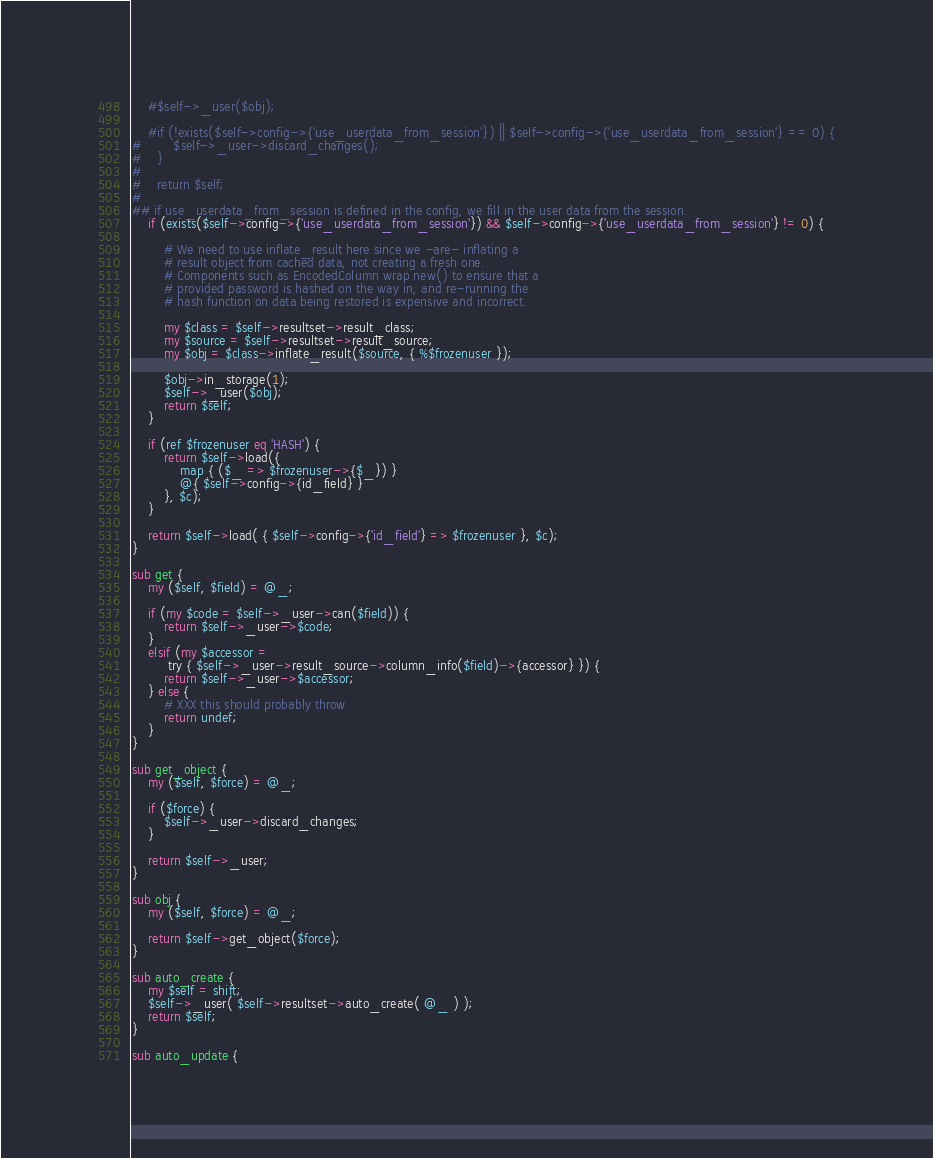Convert code to text. <code><loc_0><loc_0><loc_500><loc_500><_Perl_>    #$self->_user($obj);

    #if (!exists($self->config->{'use_userdata_from_session'}) || $self->config->{'use_userdata_from_session'} == 0) {
#        $self->_user->discard_changes();
#    }
#
#    return $self;
#
## if use_userdata_from_session is defined in the config, we fill in the user data from the session.
    if (exists($self->config->{'use_userdata_from_session'}) && $self->config->{'use_userdata_from_session'} != 0) {

        # We need to use inflate_result here since we -are- inflating a
        # result object from cached data, not creating a fresh one.
        # Components such as EncodedColumn wrap new() to ensure that a
        # provided password is hashed on the way in, and re-running the
        # hash function on data being restored is expensive and incorrect.

        my $class = $self->resultset->result_class;
        my $source = $self->resultset->result_source;
        my $obj = $class->inflate_result($source, { %$frozenuser });

        $obj->in_storage(1);
        $self->_user($obj);
        return $self;
    }

    if (ref $frozenuser eq 'HASH') {
        return $self->load({
            map { ($_ => $frozenuser->{$_}) }
            @{ $self->config->{id_field} }
        }, $c);
    }

    return $self->load( { $self->config->{'id_field'} => $frozenuser }, $c);
}

sub get {
    my ($self, $field) = @_;

    if (my $code = $self->_user->can($field)) {
        return $self->_user->$code;
    }
    elsif (my $accessor =
         try { $self->_user->result_source->column_info($field)->{accessor} }) {
        return $self->_user->$accessor;
    } else {
        # XXX this should probably throw
        return undef;
    }
}

sub get_object {
    my ($self, $force) = @_;

    if ($force) {
        $self->_user->discard_changes;
    }

    return $self->_user;
}

sub obj {
    my ($self, $force) = @_;

    return $self->get_object($force);
}

sub auto_create {
    my $self = shift;
    $self->_user( $self->resultset->auto_create( @_ ) );
    return $self;
}

sub auto_update {</code> 